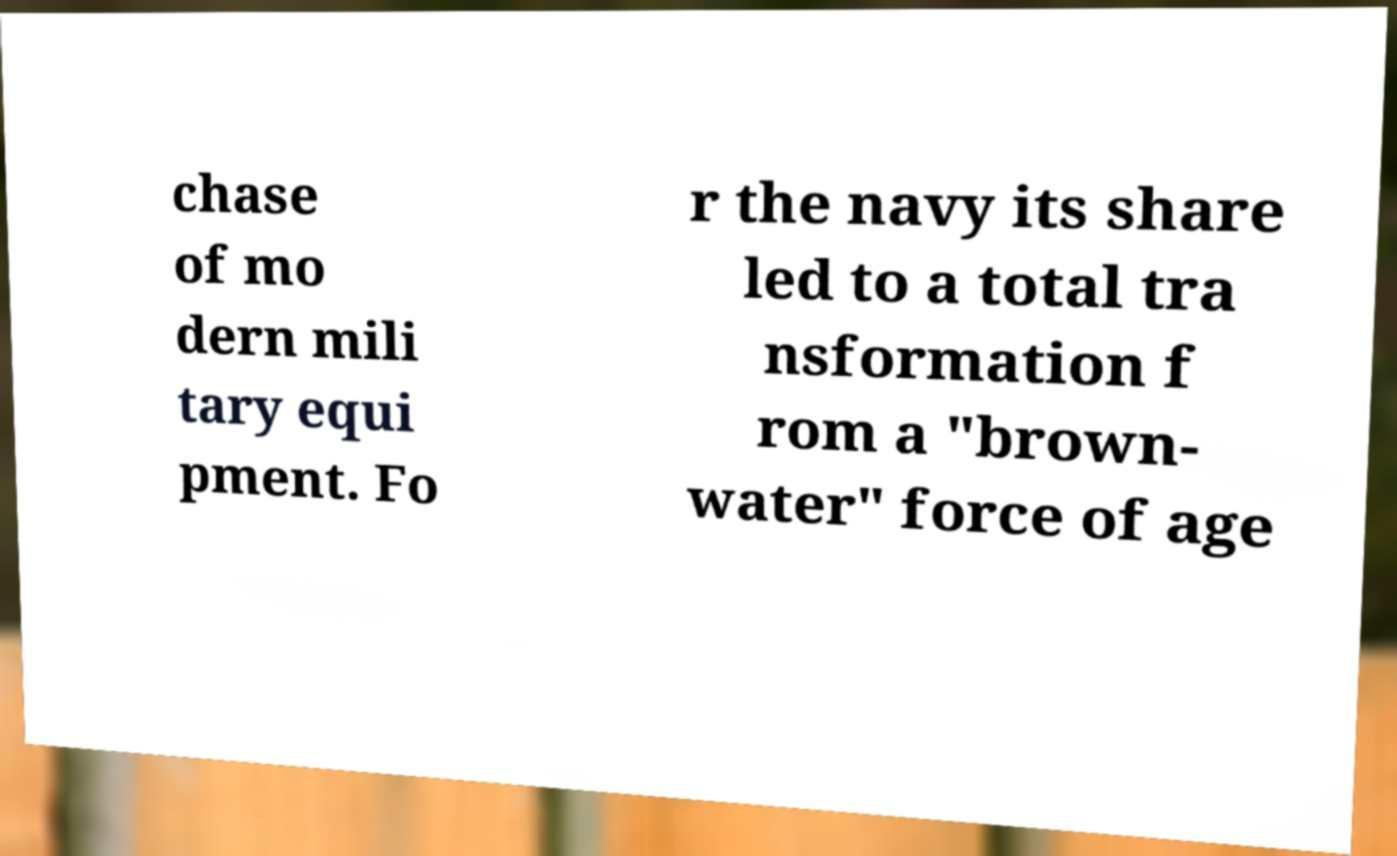There's text embedded in this image that I need extracted. Can you transcribe it verbatim? chase of mo dern mili tary equi pment. Fo r the navy its share led to a total tra nsformation f rom a "brown- water" force of age 